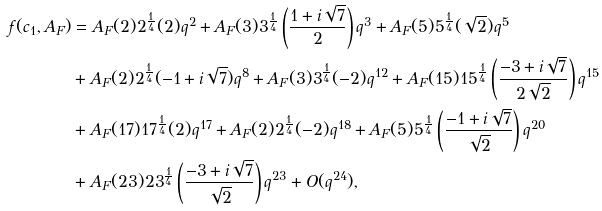<formula> <loc_0><loc_0><loc_500><loc_500>f ( c _ { 1 } , A _ { F } ) & = A _ { F } ( 2 ) 2 ^ { \frac { 1 } { 4 } } ( 2 ) q ^ { 2 } + A _ { F } ( 3 ) 3 ^ { \frac { 1 } { 4 } } \left ( \frac { 1 + i \sqrt { 7 } } { 2 } \right ) q ^ { 3 } + A _ { F } ( 5 ) 5 ^ { \frac { 1 } { 4 } } ( \sqrt { 2 } ) q ^ { 5 } \\ & + A _ { F } ( 2 ) 2 ^ { \frac { 1 } { 4 } } ( - 1 + i \sqrt { 7 } ) q ^ { 8 } + A _ { F } ( 3 ) 3 ^ { \frac { 1 } { 4 } } ( - 2 ) q ^ { 1 2 } + A _ { F } ( 1 5 ) 1 5 ^ { \frac { 1 } { 4 } } \left ( \frac { - 3 + i \sqrt { 7 } } { 2 \sqrt { 2 } } \right ) q ^ { 1 5 } \\ & + A _ { F } ( 1 7 ) 1 7 ^ { \frac { 1 } { 4 } } ( 2 ) q ^ { 1 7 } + A _ { F } ( 2 ) 2 ^ { \frac { 1 } { 4 } } ( - 2 ) q ^ { 1 8 } + A _ { F } ( 5 ) 5 ^ { \frac { 1 } { 4 } } \left ( \frac { - 1 + i \sqrt { 7 } } { \sqrt { 2 } } \right ) q ^ { 2 0 } \\ & + A _ { F } ( 2 3 ) 2 3 ^ { \frac { 1 } { 4 } } \left ( \frac { - 3 + i \sqrt { 7 } } { \sqrt { 2 } } \right ) q ^ { 2 3 } + O ( q ^ { 2 4 } ) ,</formula> 